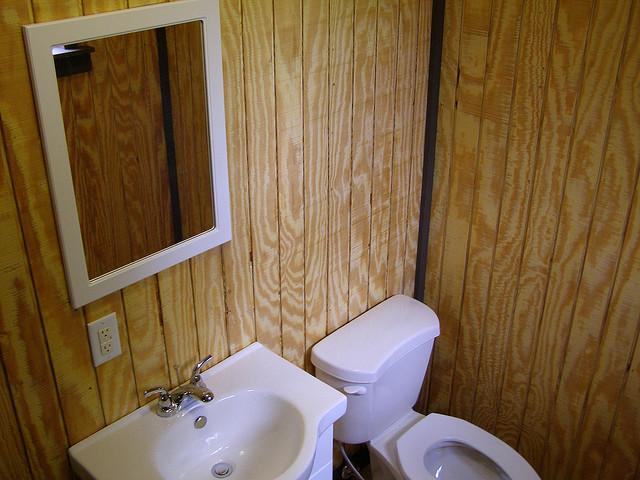Is this a smaller than normal restroom?
Quick response, please. Yes. What kind of walls are these?
Concise answer only. Wood panel. Where is the mirror?
Write a very short answer. Wall. 